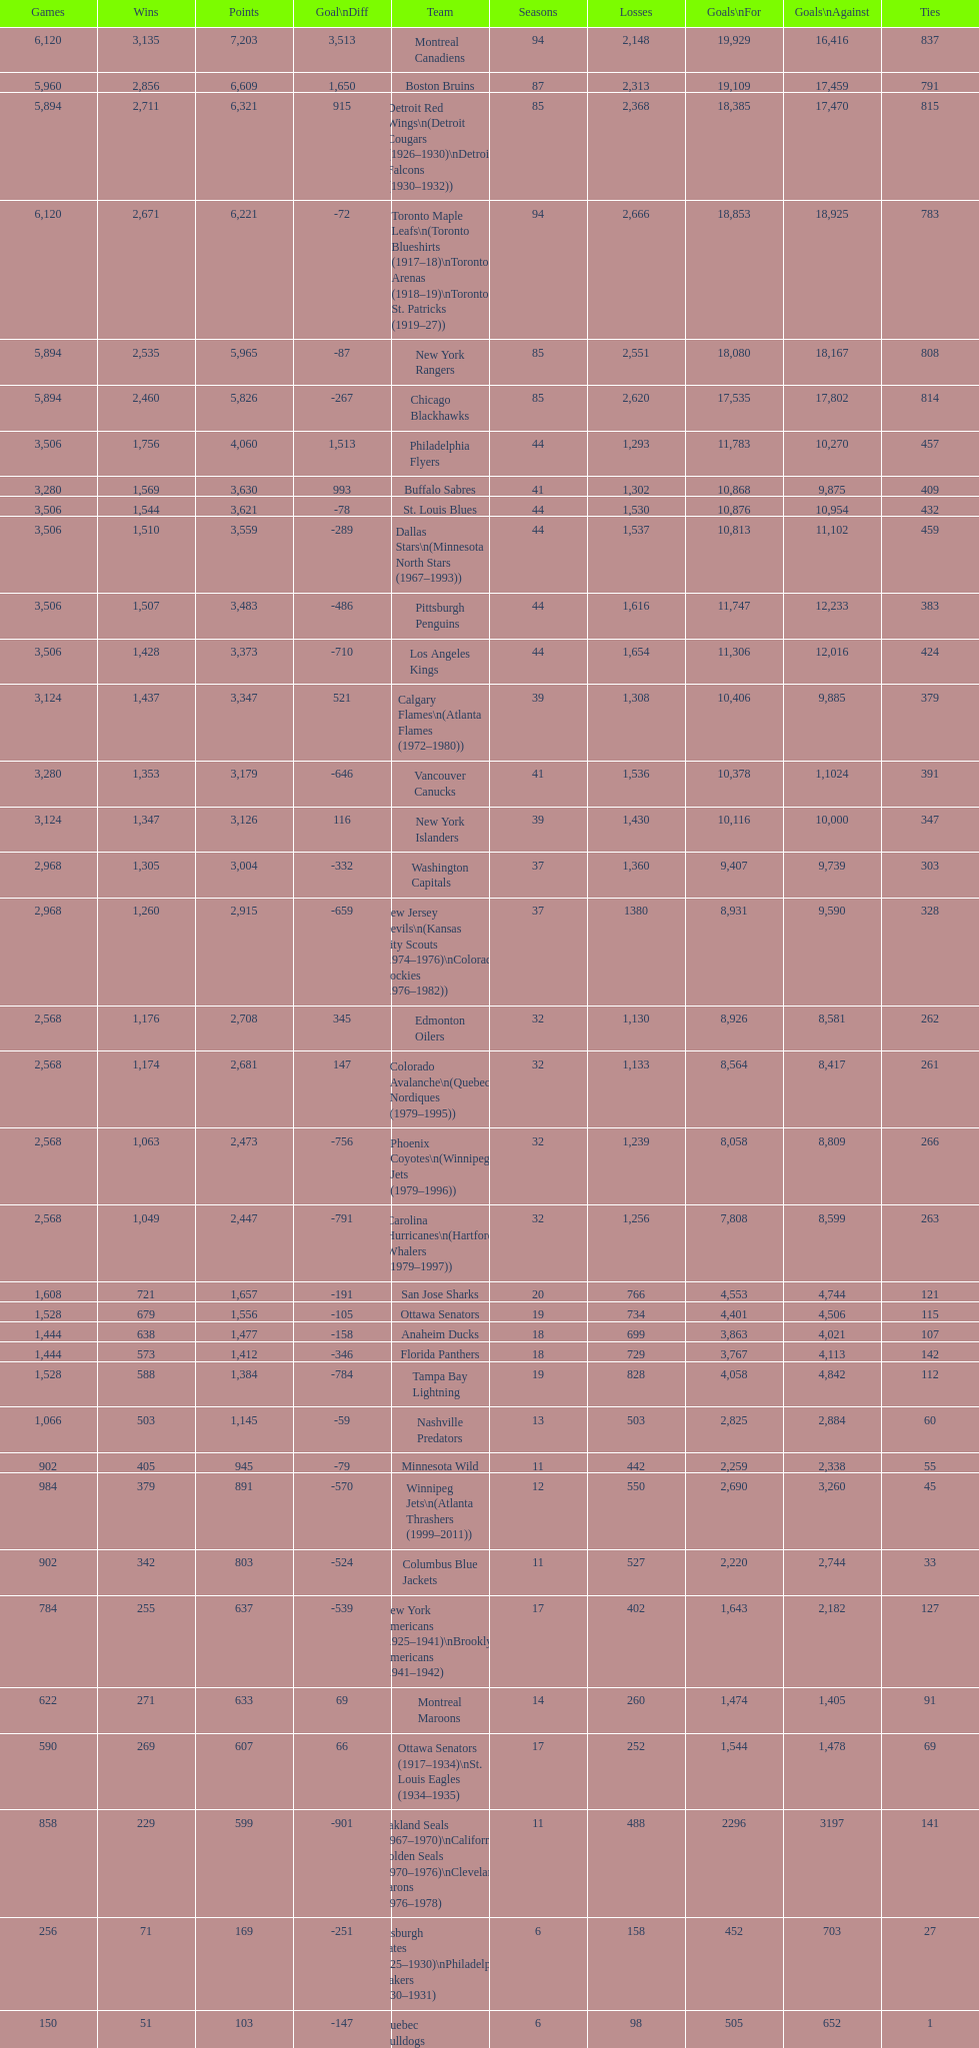How many losses do the st. louis blues have? 1,530. 